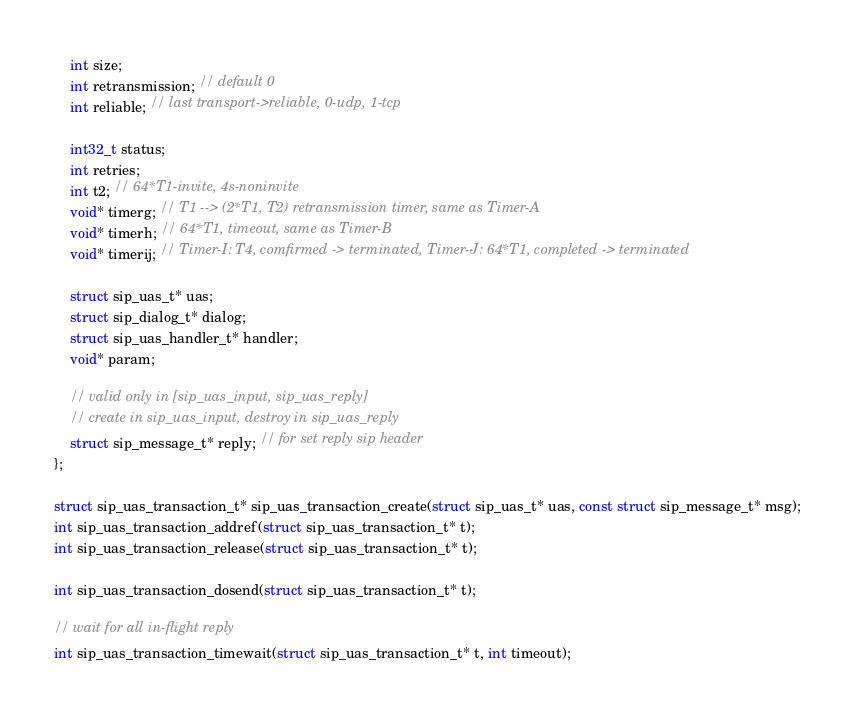<code> <loc_0><loc_0><loc_500><loc_500><_C_>	int size;
	int retransmission; // default 0
	int reliable; // last transport->reliable, 0-udp, 1-tcp

	int32_t status;
	int retries;
	int t2; // 64*T1-invite, 4s-noninvite
	void* timerg; // T1 --> (2*T1, T2) retransmission timer, same as Timer-A
	void* timerh; // 64*T1, timeout, same as Timer-B
	void* timerij; // Timer-I: T4, comfirmed -> terminated, Timer-J: 64*T1, completed -> terminated

	struct sip_uas_t* uas;
	struct sip_dialog_t* dialog;
	struct sip_uas_handler_t* handler;
	void* param;

	// valid only in [sip_uas_input, sip_uas_reply]
	// create in sip_uas_input, destroy in sip_uas_reply
	struct sip_message_t* reply; // for set reply sip header
};

struct sip_uas_transaction_t* sip_uas_transaction_create(struct sip_uas_t* uas, const struct sip_message_t* msg);
int sip_uas_transaction_addref(struct sip_uas_transaction_t* t);
int sip_uas_transaction_release(struct sip_uas_transaction_t* t);

int sip_uas_transaction_dosend(struct sip_uas_transaction_t* t);

// wait for all in-flight reply
int sip_uas_transaction_timewait(struct sip_uas_transaction_t* t, int timeout);
</code> 